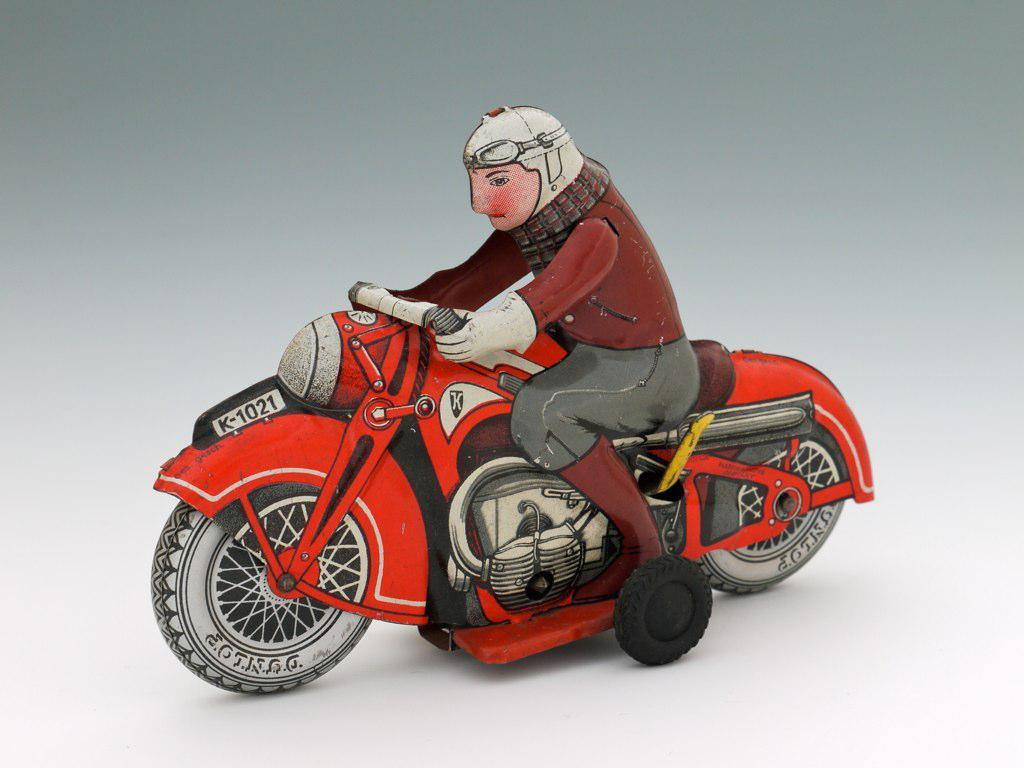What type of image is depicted in the picture? The image contains an animated picture of a person. What is the person wearing in the image? The person is wearing clothes, gloves, a helmet, goggles, and shoes in the image. What is the person doing in the image? The person is sitting on a bike in the image. What type of religion is practiced by the person in the image? There is no indication of religion in the image, as it features an animated person sitting on a bike. How many muscles can be seen on the person's arms in the image? The image is an animated picture, and muscles are not visible in the same way as they would be in a photograph of a real person. --- Facts: 1. There is a person holding a book in the image. 2. The book has a blue cover. 3. The person is sitting on a chair. 4. There is There is a table in the image. 5. The table has a lamp on it. Absurd Topics: elephant, ocean, dance Conversation: What is the person in the image holding? The person in the image is holding a book. What color is the book's cover? The book's cover is blue. Where is the person sitting in the image? The person is sitting on a chair. What is on the table in the image? There is a lamp on the table in the image. Reasoning: Let's think step by step in order to produce the conversation. We start by identifying the main subject of the image, which is the person holding a book. Then, we describe the book's cover color, which is blue. Next, we mention the person's location, which is sitting on a chair. Finally, we describe the table's contents, which include a lamp. Each question is designed to elicit a specific detail about the image that is known from the provided facts. Absurd Question/Answer: Can you see an elephant swimming in the ocean in the image? There is no elephant or ocean present in the image; it features a person sitting on a chair holding a book with a blue cover and a table with a lamp on it. 